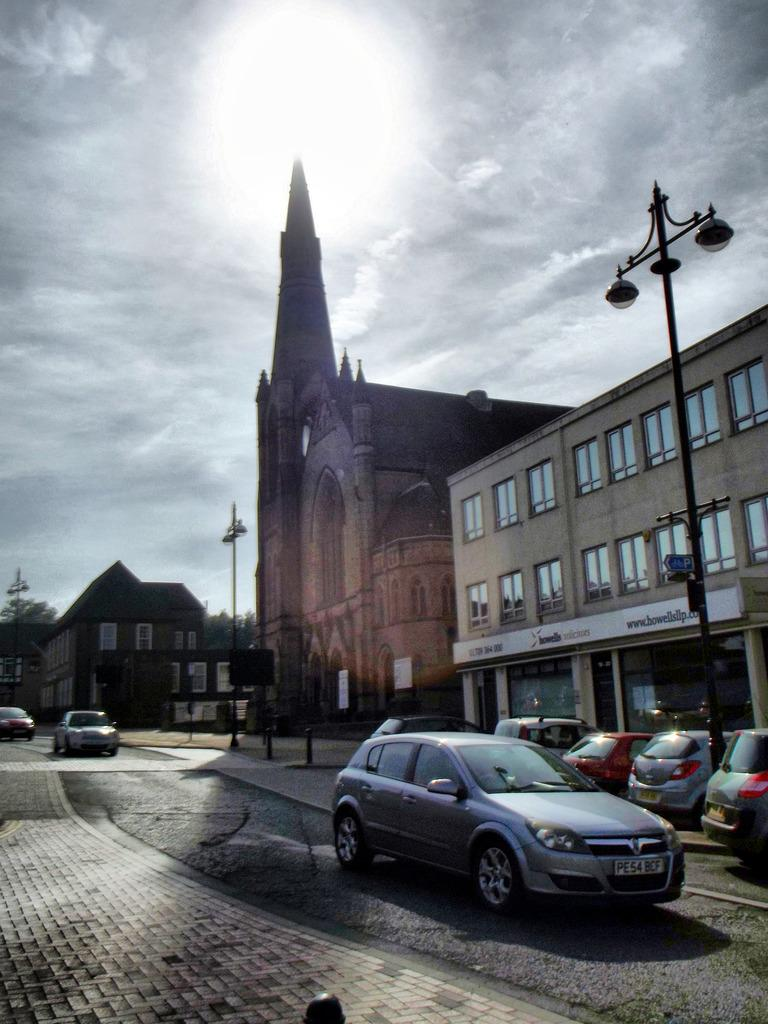What type of vehicles can be seen on the road in the image? There are cars on the road in the image. What can be seen in the distance behind the cars? There are buildings, street lights, trees, and the sky visible in the background of the image. What type of bone can be seen in the image? There is no bone present in the image. How many ears can be seen on the cars in the image? Cars do not have ears; they are vehicles and not living beings. 